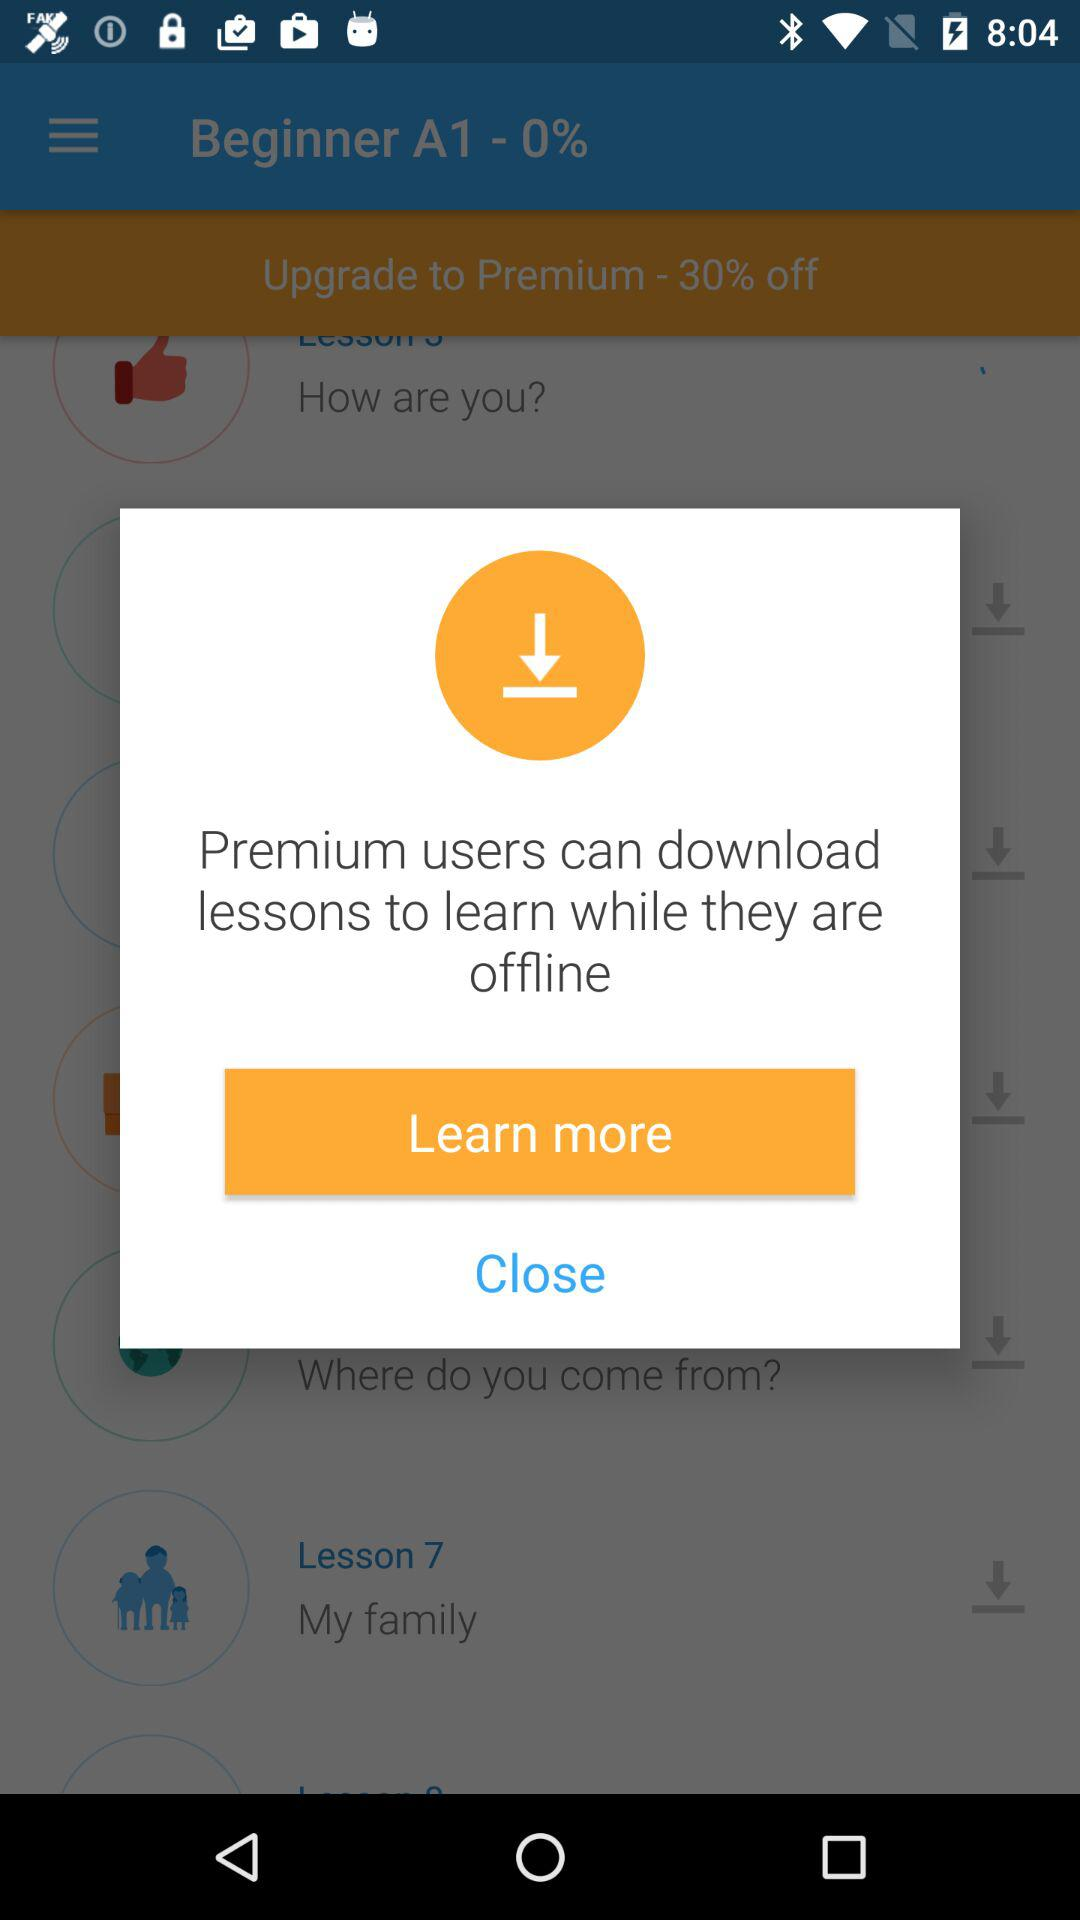How much of the percentage is off for becoming a premium user? The percentage off is 30. 